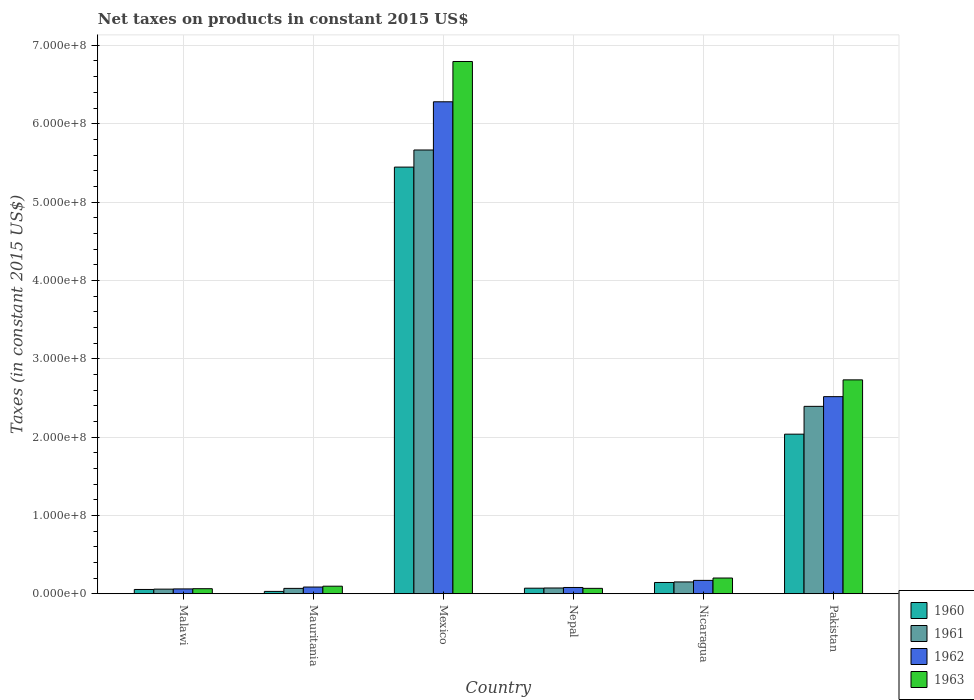Are the number of bars on each tick of the X-axis equal?
Your answer should be compact. Yes. How many bars are there on the 3rd tick from the left?
Offer a terse response. 4. What is the label of the 4th group of bars from the left?
Your response must be concise. Nepal. What is the net taxes on products in 1962 in Mauritania?
Offer a terse response. 8.56e+06. Across all countries, what is the maximum net taxes on products in 1960?
Ensure brevity in your answer.  5.45e+08. Across all countries, what is the minimum net taxes on products in 1960?
Offer a very short reply. 3.00e+06. In which country was the net taxes on products in 1962 minimum?
Provide a succinct answer. Malawi. What is the total net taxes on products in 1960 in the graph?
Your answer should be very brief. 7.78e+08. What is the difference between the net taxes on products in 1962 in Malawi and that in Mexico?
Your answer should be compact. -6.22e+08. What is the difference between the net taxes on products in 1961 in Mexico and the net taxes on products in 1963 in Nicaragua?
Ensure brevity in your answer.  5.46e+08. What is the average net taxes on products in 1962 per country?
Make the answer very short. 1.53e+08. What is the difference between the net taxes on products of/in 1962 and net taxes on products of/in 1961 in Malawi?
Keep it short and to the point. 2.80e+05. In how many countries, is the net taxes on products in 1962 greater than 380000000 US$?
Give a very brief answer. 1. What is the ratio of the net taxes on products in 1961 in Malawi to that in Nepal?
Your response must be concise. 0.8. Is the net taxes on products in 1960 in Malawi less than that in Nicaragua?
Your answer should be compact. Yes. What is the difference between the highest and the second highest net taxes on products in 1962?
Give a very brief answer. 2.35e+08. What is the difference between the highest and the lowest net taxes on products in 1961?
Provide a short and direct response. 5.61e+08. In how many countries, is the net taxes on products in 1961 greater than the average net taxes on products in 1961 taken over all countries?
Your answer should be compact. 2. Is it the case that in every country, the sum of the net taxes on products in 1963 and net taxes on products in 1962 is greater than the net taxes on products in 1960?
Your response must be concise. Yes. How many bars are there?
Offer a very short reply. 24. Are all the bars in the graph horizontal?
Provide a succinct answer. No. What is the difference between two consecutive major ticks on the Y-axis?
Offer a terse response. 1.00e+08. Does the graph contain grids?
Keep it short and to the point. Yes. How many legend labels are there?
Offer a terse response. 4. How are the legend labels stacked?
Your answer should be compact. Vertical. What is the title of the graph?
Provide a short and direct response. Net taxes on products in constant 2015 US$. What is the label or title of the Y-axis?
Keep it short and to the point. Taxes (in constant 2015 US$). What is the Taxes (in constant 2015 US$) of 1960 in Malawi?
Make the answer very short. 5.46e+06. What is the Taxes (in constant 2015 US$) of 1961 in Malawi?
Your answer should be compact. 5.88e+06. What is the Taxes (in constant 2015 US$) of 1962 in Malawi?
Keep it short and to the point. 6.16e+06. What is the Taxes (in constant 2015 US$) in 1963 in Malawi?
Your answer should be very brief. 6.44e+06. What is the Taxes (in constant 2015 US$) of 1960 in Mauritania?
Provide a short and direct response. 3.00e+06. What is the Taxes (in constant 2015 US$) of 1961 in Mauritania?
Make the answer very short. 6.85e+06. What is the Taxes (in constant 2015 US$) in 1962 in Mauritania?
Provide a succinct answer. 8.56e+06. What is the Taxes (in constant 2015 US$) of 1963 in Mauritania?
Keep it short and to the point. 9.63e+06. What is the Taxes (in constant 2015 US$) in 1960 in Mexico?
Your answer should be very brief. 5.45e+08. What is the Taxes (in constant 2015 US$) in 1961 in Mexico?
Your answer should be very brief. 5.66e+08. What is the Taxes (in constant 2015 US$) of 1962 in Mexico?
Provide a short and direct response. 6.28e+08. What is the Taxes (in constant 2015 US$) of 1963 in Mexico?
Your response must be concise. 6.79e+08. What is the Taxes (in constant 2015 US$) of 1960 in Nepal?
Ensure brevity in your answer.  7.09e+06. What is the Taxes (in constant 2015 US$) in 1961 in Nepal?
Ensure brevity in your answer.  7.35e+06. What is the Taxes (in constant 2015 US$) in 1962 in Nepal?
Make the answer very short. 8.01e+06. What is the Taxes (in constant 2015 US$) of 1963 in Nepal?
Your answer should be compact. 6.89e+06. What is the Taxes (in constant 2015 US$) in 1960 in Nicaragua?
Make the answer very short. 1.44e+07. What is the Taxes (in constant 2015 US$) of 1961 in Nicaragua?
Ensure brevity in your answer.  1.51e+07. What is the Taxes (in constant 2015 US$) of 1962 in Nicaragua?
Your answer should be compact. 1.71e+07. What is the Taxes (in constant 2015 US$) of 1963 in Nicaragua?
Ensure brevity in your answer.  2.01e+07. What is the Taxes (in constant 2015 US$) of 1960 in Pakistan?
Provide a succinct answer. 2.04e+08. What is the Taxes (in constant 2015 US$) of 1961 in Pakistan?
Make the answer very short. 2.39e+08. What is the Taxes (in constant 2015 US$) of 1962 in Pakistan?
Keep it short and to the point. 2.52e+08. What is the Taxes (in constant 2015 US$) of 1963 in Pakistan?
Make the answer very short. 2.73e+08. Across all countries, what is the maximum Taxes (in constant 2015 US$) in 1960?
Make the answer very short. 5.45e+08. Across all countries, what is the maximum Taxes (in constant 2015 US$) in 1961?
Ensure brevity in your answer.  5.66e+08. Across all countries, what is the maximum Taxes (in constant 2015 US$) of 1962?
Give a very brief answer. 6.28e+08. Across all countries, what is the maximum Taxes (in constant 2015 US$) in 1963?
Provide a succinct answer. 6.79e+08. Across all countries, what is the minimum Taxes (in constant 2015 US$) in 1960?
Your response must be concise. 3.00e+06. Across all countries, what is the minimum Taxes (in constant 2015 US$) in 1961?
Your answer should be compact. 5.88e+06. Across all countries, what is the minimum Taxes (in constant 2015 US$) in 1962?
Your response must be concise. 6.16e+06. Across all countries, what is the minimum Taxes (in constant 2015 US$) of 1963?
Your response must be concise. 6.44e+06. What is the total Taxes (in constant 2015 US$) of 1960 in the graph?
Provide a succinct answer. 7.78e+08. What is the total Taxes (in constant 2015 US$) of 1961 in the graph?
Your response must be concise. 8.41e+08. What is the total Taxes (in constant 2015 US$) in 1962 in the graph?
Give a very brief answer. 9.19e+08. What is the total Taxes (in constant 2015 US$) in 1963 in the graph?
Provide a succinct answer. 9.95e+08. What is the difference between the Taxes (in constant 2015 US$) in 1960 in Malawi and that in Mauritania?
Keep it short and to the point. 2.46e+06. What is the difference between the Taxes (in constant 2015 US$) of 1961 in Malawi and that in Mauritania?
Provide a succinct answer. -9.67e+05. What is the difference between the Taxes (in constant 2015 US$) of 1962 in Malawi and that in Mauritania?
Make the answer very short. -2.40e+06. What is the difference between the Taxes (in constant 2015 US$) of 1963 in Malawi and that in Mauritania?
Your response must be concise. -3.19e+06. What is the difference between the Taxes (in constant 2015 US$) in 1960 in Malawi and that in Mexico?
Keep it short and to the point. -5.39e+08. What is the difference between the Taxes (in constant 2015 US$) in 1961 in Malawi and that in Mexico?
Your answer should be very brief. -5.61e+08. What is the difference between the Taxes (in constant 2015 US$) of 1962 in Malawi and that in Mexico?
Provide a succinct answer. -6.22e+08. What is the difference between the Taxes (in constant 2015 US$) in 1963 in Malawi and that in Mexico?
Provide a short and direct response. -6.73e+08. What is the difference between the Taxes (in constant 2015 US$) in 1960 in Malawi and that in Nepal?
Provide a succinct answer. -1.63e+06. What is the difference between the Taxes (in constant 2015 US$) in 1961 in Malawi and that in Nepal?
Provide a short and direct response. -1.47e+06. What is the difference between the Taxes (in constant 2015 US$) in 1962 in Malawi and that in Nepal?
Ensure brevity in your answer.  -1.85e+06. What is the difference between the Taxes (in constant 2015 US$) of 1963 in Malawi and that in Nepal?
Provide a short and direct response. -4.50e+05. What is the difference between the Taxes (in constant 2015 US$) of 1960 in Malawi and that in Nicaragua?
Your answer should be very brief. -8.93e+06. What is the difference between the Taxes (in constant 2015 US$) of 1961 in Malawi and that in Nicaragua?
Your answer should be compact. -9.18e+06. What is the difference between the Taxes (in constant 2015 US$) of 1962 in Malawi and that in Nicaragua?
Provide a short and direct response. -1.09e+07. What is the difference between the Taxes (in constant 2015 US$) in 1963 in Malawi and that in Nicaragua?
Offer a terse response. -1.36e+07. What is the difference between the Taxes (in constant 2015 US$) in 1960 in Malawi and that in Pakistan?
Provide a succinct answer. -1.98e+08. What is the difference between the Taxes (in constant 2015 US$) of 1961 in Malawi and that in Pakistan?
Offer a terse response. -2.33e+08. What is the difference between the Taxes (in constant 2015 US$) of 1962 in Malawi and that in Pakistan?
Offer a very short reply. -2.45e+08. What is the difference between the Taxes (in constant 2015 US$) of 1963 in Malawi and that in Pakistan?
Your answer should be very brief. -2.67e+08. What is the difference between the Taxes (in constant 2015 US$) in 1960 in Mauritania and that in Mexico?
Make the answer very short. -5.42e+08. What is the difference between the Taxes (in constant 2015 US$) of 1961 in Mauritania and that in Mexico?
Make the answer very short. -5.60e+08. What is the difference between the Taxes (in constant 2015 US$) in 1962 in Mauritania and that in Mexico?
Your answer should be very brief. -6.19e+08. What is the difference between the Taxes (in constant 2015 US$) of 1963 in Mauritania and that in Mexico?
Offer a very short reply. -6.70e+08. What is the difference between the Taxes (in constant 2015 US$) of 1960 in Mauritania and that in Nepal?
Give a very brief answer. -4.09e+06. What is the difference between the Taxes (in constant 2015 US$) of 1961 in Mauritania and that in Nepal?
Offer a very short reply. -5.03e+05. What is the difference between the Taxes (in constant 2015 US$) of 1962 in Mauritania and that in Nepal?
Your answer should be very brief. 5.53e+05. What is the difference between the Taxes (in constant 2015 US$) in 1963 in Mauritania and that in Nepal?
Offer a terse response. 2.74e+06. What is the difference between the Taxes (in constant 2015 US$) in 1960 in Mauritania and that in Nicaragua?
Provide a succinct answer. -1.14e+07. What is the difference between the Taxes (in constant 2015 US$) of 1961 in Mauritania and that in Nicaragua?
Keep it short and to the point. -8.21e+06. What is the difference between the Taxes (in constant 2015 US$) in 1962 in Mauritania and that in Nicaragua?
Your response must be concise. -8.50e+06. What is the difference between the Taxes (in constant 2015 US$) of 1963 in Mauritania and that in Nicaragua?
Offer a terse response. -1.04e+07. What is the difference between the Taxes (in constant 2015 US$) of 1960 in Mauritania and that in Pakistan?
Ensure brevity in your answer.  -2.01e+08. What is the difference between the Taxes (in constant 2015 US$) of 1961 in Mauritania and that in Pakistan?
Your answer should be compact. -2.32e+08. What is the difference between the Taxes (in constant 2015 US$) in 1962 in Mauritania and that in Pakistan?
Ensure brevity in your answer.  -2.43e+08. What is the difference between the Taxes (in constant 2015 US$) of 1963 in Mauritania and that in Pakistan?
Your answer should be compact. -2.63e+08. What is the difference between the Taxes (in constant 2015 US$) of 1960 in Mexico and that in Nepal?
Your response must be concise. 5.37e+08. What is the difference between the Taxes (in constant 2015 US$) of 1961 in Mexico and that in Nepal?
Offer a terse response. 5.59e+08. What is the difference between the Taxes (in constant 2015 US$) of 1962 in Mexico and that in Nepal?
Make the answer very short. 6.20e+08. What is the difference between the Taxes (in constant 2015 US$) in 1963 in Mexico and that in Nepal?
Provide a short and direct response. 6.72e+08. What is the difference between the Taxes (in constant 2015 US$) in 1960 in Mexico and that in Nicaragua?
Make the answer very short. 5.30e+08. What is the difference between the Taxes (in constant 2015 US$) of 1961 in Mexico and that in Nicaragua?
Provide a short and direct response. 5.51e+08. What is the difference between the Taxes (in constant 2015 US$) in 1962 in Mexico and that in Nicaragua?
Provide a succinct answer. 6.11e+08. What is the difference between the Taxes (in constant 2015 US$) in 1963 in Mexico and that in Nicaragua?
Provide a succinct answer. 6.59e+08. What is the difference between the Taxes (in constant 2015 US$) of 1960 in Mexico and that in Pakistan?
Your answer should be compact. 3.41e+08. What is the difference between the Taxes (in constant 2015 US$) of 1961 in Mexico and that in Pakistan?
Make the answer very short. 3.27e+08. What is the difference between the Taxes (in constant 2015 US$) of 1962 in Mexico and that in Pakistan?
Your response must be concise. 3.76e+08. What is the difference between the Taxes (in constant 2015 US$) in 1963 in Mexico and that in Pakistan?
Your answer should be compact. 4.06e+08. What is the difference between the Taxes (in constant 2015 US$) in 1960 in Nepal and that in Nicaragua?
Offer a terse response. -7.30e+06. What is the difference between the Taxes (in constant 2015 US$) in 1961 in Nepal and that in Nicaragua?
Ensure brevity in your answer.  -7.71e+06. What is the difference between the Taxes (in constant 2015 US$) in 1962 in Nepal and that in Nicaragua?
Your response must be concise. -9.06e+06. What is the difference between the Taxes (in constant 2015 US$) in 1963 in Nepal and that in Nicaragua?
Offer a terse response. -1.32e+07. What is the difference between the Taxes (in constant 2015 US$) of 1960 in Nepal and that in Pakistan?
Your response must be concise. -1.97e+08. What is the difference between the Taxes (in constant 2015 US$) in 1961 in Nepal and that in Pakistan?
Your answer should be compact. -2.32e+08. What is the difference between the Taxes (in constant 2015 US$) in 1962 in Nepal and that in Pakistan?
Ensure brevity in your answer.  -2.44e+08. What is the difference between the Taxes (in constant 2015 US$) of 1963 in Nepal and that in Pakistan?
Offer a terse response. -2.66e+08. What is the difference between the Taxes (in constant 2015 US$) of 1960 in Nicaragua and that in Pakistan?
Your answer should be compact. -1.89e+08. What is the difference between the Taxes (in constant 2015 US$) of 1961 in Nicaragua and that in Pakistan?
Give a very brief answer. -2.24e+08. What is the difference between the Taxes (in constant 2015 US$) in 1962 in Nicaragua and that in Pakistan?
Provide a short and direct response. -2.35e+08. What is the difference between the Taxes (in constant 2015 US$) in 1963 in Nicaragua and that in Pakistan?
Provide a succinct answer. -2.53e+08. What is the difference between the Taxes (in constant 2015 US$) of 1960 in Malawi and the Taxes (in constant 2015 US$) of 1961 in Mauritania?
Offer a terse response. -1.39e+06. What is the difference between the Taxes (in constant 2015 US$) of 1960 in Malawi and the Taxes (in constant 2015 US$) of 1962 in Mauritania?
Your response must be concise. -3.10e+06. What is the difference between the Taxes (in constant 2015 US$) in 1960 in Malawi and the Taxes (in constant 2015 US$) in 1963 in Mauritania?
Your answer should be very brief. -4.17e+06. What is the difference between the Taxes (in constant 2015 US$) of 1961 in Malawi and the Taxes (in constant 2015 US$) of 1962 in Mauritania?
Your answer should be very brief. -2.68e+06. What is the difference between the Taxes (in constant 2015 US$) of 1961 in Malawi and the Taxes (in constant 2015 US$) of 1963 in Mauritania?
Provide a short and direct response. -3.75e+06. What is the difference between the Taxes (in constant 2015 US$) of 1962 in Malawi and the Taxes (in constant 2015 US$) of 1963 in Mauritania?
Offer a very short reply. -3.47e+06. What is the difference between the Taxes (in constant 2015 US$) in 1960 in Malawi and the Taxes (in constant 2015 US$) in 1961 in Mexico?
Ensure brevity in your answer.  -5.61e+08. What is the difference between the Taxes (in constant 2015 US$) in 1960 in Malawi and the Taxes (in constant 2015 US$) in 1962 in Mexico?
Make the answer very short. -6.22e+08. What is the difference between the Taxes (in constant 2015 US$) in 1960 in Malawi and the Taxes (in constant 2015 US$) in 1963 in Mexico?
Your answer should be very brief. -6.74e+08. What is the difference between the Taxes (in constant 2015 US$) in 1961 in Malawi and the Taxes (in constant 2015 US$) in 1962 in Mexico?
Your answer should be compact. -6.22e+08. What is the difference between the Taxes (in constant 2015 US$) of 1961 in Malawi and the Taxes (in constant 2015 US$) of 1963 in Mexico?
Offer a very short reply. -6.73e+08. What is the difference between the Taxes (in constant 2015 US$) in 1962 in Malawi and the Taxes (in constant 2015 US$) in 1963 in Mexico?
Your answer should be compact. -6.73e+08. What is the difference between the Taxes (in constant 2015 US$) in 1960 in Malawi and the Taxes (in constant 2015 US$) in 1961 in Nepal?
Offer a very short reply. -1.89e+06. What is the difference between the Taxes (in constant 2015 US$) of 1960 in Malawi and the Taxes (in constant 2015 US$) of 1962 in Nepal?
Give a very brief answer. -2.55e+06. What is the difference between the Taxes (in constant 2015 US$) of 1960 in Malawi and the Taxes (in constant 2015 US$) of 1963 in Nepal?
Provide a succinct answer. -1.43e+06. What is the difference between the Taxes (in constant 2015 US$) of 1961 in Malawi and the Taxes (in constant 2015 US$) of 1962 in Nepal?
Ensure brevity in your answer.  -2.13e+06. What is the difference between the Taxes (in constant 2015 US$) in 1961 in Malawi and the Taxes (in constant 2015 US$) in 1963 in Nepal?
Your answer should be compact. -1.01e+06. What is the difference between the Taxes (in constant 2015 US$) in 1962 in Malawi and the Taxes (in constant 2015 US$) in 1963 in Nepal?
Offer a very short reply. -7.30e+05. What is the difference between the Taxes (in constant 2015 US$) of 1960 in Malawi and the Taxes (in constant 2015 US$) of 1961 in Nicaragua?
Keep it short and to the point. -9.60e+06. What is the difference between the Taxes (in constant 2015 US$) of 1960 in Malawi and the Taxes (in constant 2015 US$) of 1962 in Nicaragua?
Your answer should be compact. -1.16e+07. What is the difference between the Taxes (in constant 2015 US$) of 1960 in Malawi and the Taxes (in constant 2015 US$) of 1963 in Nicaragua?
Ensure brevity in your answer.  -1.46e+07. What is the difference between the Taxes (in constant 2015 US$) of 1961 in Malawi and the Taxes (in constant 2015 US$) of 1962 in Nicaragua?
Your response must be concise. -1.12e+07. What is the difference between the Taxes (in constant 2015 US$) in 1961 in Malawi and the Taxes (in constant 2015 US$) in 1963 in Nicaragua?
Make the answer very short. -1.42e+07. What is the difference between the Taxes (in constant 2015 US$) in 1962 in Malawi and the Taxes (in constant 2015 US$) in 1963 in Nicaragua?
Offer a very short reply. -1.39e+07. What is the difference between the Taxes (in constant 2015 US$) of 1960 in Malawi and the Taxes (in constant 2015 US$) of 1961 in Pakistan?
Offer a terse response. -2.34e+08. What is the difference between the Taxes (in constant 2015 US$) in 1960 in Malawi and the Taxes (in constant 2015 US$) in 1962 in Pakistan?
Your answer should be very brief. -2.46e+08. What is the difference between the Taxes (in constant 2015 US$) of 1960 in Malawi and the Taxes (in constant 2015 US$) of 1963 in Pakistan?
Your answer should be very brief. -2.68e+08. What is the difference between the Taxes (in constant 2015 US$) of 1961 in Malawi and the Taxes (in constant 2015 US$) of 1962 in Pakistan?
Keep it short and to the point. -2.46e+08. What is the difference between the Taxes (in constant 2015 US$) in 1961 in Malawi and the Taxes (in constant 2015 US$) in 1963 in Pakistan?
Offer a very short reply. -2.67e+08. What is the difference between the Taxes (in constant 2015 US$) in 1962 in Malawi and the Taxes (in constant 2015 US$) in 1963 in Pakistan?
Offer a very short reply. -2.67e+08. What is the difference between the Taxes (in constant 2015 US$) of 1960 in Mauritania and the Taxes (in constant 2015 US$) of 1961 in Mexico?
Your answer should be compact. -5.63e+08. What is the difference between the Taxes (in constant 2015 US$) of 1960 in Mauritania and the Taxes (in constant 2015 US$) of 1962 in Mexico?
Your answer should be very brief. -6.25e+08. What is the difference between the Taxes (in constant 2015 US$) in 1960 in Mauritania and the Taxes (in constant 2015 US$) in 1963 in Mexico?
Offer a very short reply. -6.76e+08. What is the difference between the Taxes (in constant 2015 US$) in 1961 in Mauritania and the Taxes (in constant 2015 US$) in 1962 in Mexico?
Your response must be concise. -6.21e+08. What is the difference between the Taxes (in constant 2015 US$) of 1961 in Mauritania and the Taxes (in constant 2015 US$) of 1963 in Mexico?
Provide a short and direct response. -6.73e+08. What is the difference between the Taxes (in constant 2015 US$) of 1962 in Mauritania and the Taxes (in constant 2015 US$) of 1963 in Mexico?
Provide a succinct answer. -6.71e+08. What is the difference between the Taxes (in constant 2015 US$) in 1960 in Mauritania and the Taxes (in constant 2015 US$) in 1961 in Nepal?
Provide a short and direct response. -4.35e+06. What is the difference between the Taxes (in constant 2015 US$) in 1960 in Mauritania and the Taxes (in constant 2015 US$) in 1962 in Nepal?
Keep it short and to the point. -5.01e+06. What is the difference between the Taxes (in constant 2015 US$) of 1960 in Mauritania and the Taxes (in constant 2015 US$) of 1963 in Nepal?
Give a very brief answer. -3.89e+06. What is the difference between the Taxes (in constant 2015 US$) of 1961 in Mauritania and the Taxes (in constant 2015 US$) of 1962 in Nepal?
Your response must be concise. -1.16e+06. What is the difference between the Taxes (in constant 2015 US$) in 1961 in Mauritania and the Taxes (in constant 2015 US$) in 1963 in Nepal?
Keep it short and to the point. -4.29e+04. What is the difference between the Taxes (in constant 2015 US$) of 1962 in Mauritania and the Taxes (in constant 2015 US$) of 1963 in Nepal?
Offer a terse response. 1.67e+06. What is the difference between the Taxes (in constant 2015 US$) of 1960 in Mauritania and the Taxes (in constant 2015 US$) of 1961 in Nicaragua?
Keep it short and to the point. -1.21e+07. What is the difference between the Taxes (in constant 2015 US$) in 1960 in Mauritania and the Taxes (in constant 2015 US$) in 1962 in Nicaragua?
Make the answer very short. -1.41e+07. What is the difference between the Taxes (in constant 2015 US$) of 1960 in Mauritania and the Taxes (in constant 2015 US$) of 1963 in Nicaragua?
Your answer should be compact. -1.71e+07. What is the difference between the Taxes (in constant 2015 US$) in 1961 in Mauritania and the Taxes (in constant 2015 US$) in 1962 in Nicaragua?
Offer a terse response. -1.02e+07. What is the difference between the Taxes (in constant 2015 US$) of 1961 in Mauritania and the Taxes (in constant 2015 US$) of 1963 in Nicaragua?
Keep it short and to the point. -1.32e+07. What is the difference between the Taxes (in constant 2015 US$) of 1962 in Mauritania and the Taxes (in constant 2015 US$) of 1963 in Nicaragua?
Your answer should be compact. -1.15e+07. What is the difference between the Taxes (in constant 2015 US$) of 1960 in Mauritania and the Taxes (in constant 2015 US$) of 1961 in Pakistan?
Ensure brevity in your answer.  -2.36e+08. What is the difference between the Taxes (in constant 2015 US$) of 1960 in Mauritania and the Taxes (in constant 2015 US$) of 1962 in Pakistan?
Give a very brief answer. -2.49e+08. What is the difference between the Taxes (in constant 2015 US$) of 1960 in Mauritania and the Taxes (in constant 2015 US$) of 1963 in Pakistan?
Provide a succinct answer. -2.70e+08. What is the difference between the Taxes (in constant 2015 US$) of 1961 in Mauritania and the Taxes (in constant 2015 US$) of 1962 in Pakistan?
Offer a terse response. -2.45e+08. What is the difference between the Taxes (in constant 2015 US$) of 1961 in Mauritania and the Taxes (in constant 2015 US$) of 1963 in Pakistan?
Offer a very short reply. -2.66e+08. What is the difference between the Taxes (in constant 2015 US$) in 1962 in Mauritania and the Taxes (in constant 2015 US$) in 1963 in Pakistan?
Offer a terse response. -2.64e+08. What is the difference between the Taxes (in constant 2015 US$) of 1960 in Mexico and the Taxes (in constant 2015 US$) of 1961 in Nepal?
Offer a very short reply. 5.37e+08. What is the difference between the Taxes (in constant 2015 US$) of 1960 in Mexico and the Taxes (in constant 2015 US$) of 1962 in Nepal?
Offer a terse response. 5.37e+08. What is the difference between the Taxes (in constant 2015 US$) of 1960 in Mexico and the Taxes (in constant 2015 US$) of 1963 in Nepal?
Your response must be concise. 5.38e+08. What is the difference between the Taxes (in constant 2015 US$) in 1961 in Mexico and the Taxes (in constant 2015 US$) in 1962 in Nepal?
Give a very brief answer. 5.58e+08. What is the difference between the Taxes (in constant 2015 US$) of 1961 in Mexico and the Taxes (in constant 2015 US$) of 1963 in Nepal?
Your answer should be very brief. 5.60e+08. What is the difference between the Taxes (in constant 2015 US$) in 1962 in Mexico and the Taxes (in constant 2015 US$) in 1963 in Nepal?
Make the answer very short. 6.21e+08. What is the difference between the Taxes (in constant 2015 US$) in 1960 in Mexico and the Taxes (in constant 2015 US$) in 1961 in Nicaragua?
Offer a terse response. 5.30e+08. What is the difference between the Taxes (in constant 2015 US$) in 1960 in Mexico and the Taxes (in constant 2015 US$) in 1962 in Nicaragua?
Your answer should be very brief. 5.28e+08. What is the difference between the Taxes (in constant 2015 US$) of 1960 in Mexico and the Taxes (in constant 2015 US$) of 1963 in Nicaragua?
Your answer should be very brief. 5.24e+08. What is the difference between the Taxes (in constant 2015 US$) in 1961 in Mexico and the Taxes (in constant 2015 US$) in 1962 in Nicaragua?
Provide a succinct answer. 5.49e+08. What is the difference between the Taxes (in constant 2015 US$) of 1961 in Mexico and the Taxes (in constant 2015 US$) of 1963 in Nicaragua?
Give a very brief answer. 5.46e+08. What is the difference between the Taxes (in constant 2015 US$) in 1962 in Mexico and the Taxes (in constant 2015 US$) in 1963 in Nicaragua?
Offer a terse response. 6.08e+08. What is the difference between the Taxes (in constant 2015 US$) of 1960 in Mexico and the Taxes (in constant 2015 US$) of 1961 in Pakistan?
Your answer should be very brief. 3.05e+08. What is the difference between the Taxes (in constant 2015 US$) of 1960 in Mexico and the Taxes (in constant 2015 US$) of 1962 in Pakistan?
Offer a very short reply. 2.93e+08. What is the difference between the Taxes (in constant 2015 US$) of 1960 in Mexico and the Taxes (in constant 2015 US$) of 1963 in Pakistan?
Provide a short and direct response. 2.72e+08. What is the difference between the Taxes (in constant 2015 US$) in 1961 in Mexico and the Taxes (in constant 2015 US$) in 1962 in Pakistan?
Ensure brevity in your answer.  3.15e+08. What is the difference between the Taxes (in constant 2015 US$) of 1961 in Mexico and the Taxes (in constant 2015 US$) of 1963 in Pakistan?
Your answer should be very brief. 2.93e+08. What is the difference between the Taxes (in constant 2015 US$) of 1962 in Mexico and the Taxes (in constant 2015 US$) of 1963 in Pakistan?
Offer a terse response. 3.55e+08. What is the difference between the Taxes (in constant 2015 US$) in 1960 in Nepal and the Taxes (in constant 2015 US$) in 1961 in Nicaragua?
Offer a very short reply. -7.97e+06. What is the difference between the Taxes (in constant 2015 US$) in 1960 in Nepal and the Taxes (in constant 2015 US$) in 1962 in Nicaragua?
Provide a succinct answer. -9.98e+06. What is the difference between the Taxes (in constant 2015 US$) of 1960 in Nepal and the Taxes (in constant 2015 US$) of 1963 in Nicaragua?
Offer a very short reply. -1.30e+07. What is the difference between the Taxes (in constant 2015 US$) of 1961 in Nepal and the Taxes (in constant 2015 US$) of 1962 in Nicaragua?
Your answer should be compact. -9.71e+06. What is the difference between the Taxes (in constant 2015 US$) in 1961 in Nepal and the Taxes (in constant 2015 US$) in 1963 in Nicaragua?
Provide a short and direct response. -1.27e+07. What is the difference between the Taxes (in constant 2015 US$) of 1962 in Nepal and the Taxes (in constant 2015 US$) of 1963 in Nicaragua?
Make the answer very short. -1.21e+07. What is the difference between the Taxes (in constant 2015 US$) of 1960 in Nepal and the Taxes (in constant 2015 US$) of 1961 in Pakistan?
Your answer should be very brief. -2.32e+08. What is the difference between the Taxes (in constant 2015 US$) of 1960 in Nepal and the Taxes (in constant 2015 US$) of 1962 in Pakistan?
Provide a short and direct response. -2.44e+08. What is the difference between the Taxes (in constant 2015 US$) of 1960 in Nepal and the Taxes (in constant 2015 US$) of 1963 in Pakistan?
Offer a terse response. -2.66e+08. What is the difference between the Taxes (in constant 2015 US$) in 1961 in Nepal and the Taxes (in constant 2015 US$) in 1962 in Pakistan?
Provide a short and direct response. -2.44e+08. What is the difference between the Taxes (in constant 2015 US$) of 1961 in Nepal and the Taxes (in constant 2015 US$) of 1963 in Pakistan?
Give a very brief answer. -2.66e+08. What is the difference between the Taxes (in constant 2015 US$) in 1962 in Nepal and the Taxes (in constant 2015 US$) in 1963 in Pakistan?
Ensure brevity in your answer.  -2.65e+08. What is the difference between the Taxes (in constant 2015 US$) of 1960 in Nicaragua and the Taxes (in constant 2015 US$) of 1961 in Pakistan?
Your answer should be compact. -2.25e+08. What is the difference between the Taxes (in constant 2015 US$) in 1960 in Nicaragua and the Taxes (in constant 2015 US$) in 1962 in Pakistan?
Provide a short and direct response. -2.37e+08. What is the difference between the Taxes (in constant 2015 US$) of 1960 in Nicaragua and the Taxes (in constant 2015 US$) of 1963 in Pakistan?
Provide a short and direct response. -2.59e+08. What is the difference between the Taxes (in constant 2015 US$) in 1961 in Nicaragua and the Taxes (in constant 2015 US$) in 1962 in Pakistan?
Ensure brevity in your answer.  -2.37e+08. What is the difference between the Taxes (in constant 2015 US$) in 1961 in Nicaragua and the Taxes (in constant 2015 US$) in 1963 in Pakistan?
Provide a short and direct response. -2.58e+08. What is the difference between the Taxes (in constant 2015 US$) in 1962 in Nicaragua and the Taxes (in constant 2015 US$) in 1963 in Pakistan?
Make the answer very short. -2.56e+08. What is the average Taxes (in constant 2015 US$) in 1960 per country?
Make the answer very short. 1.30e+08. What is the average Taxes (in constant 2015 US$) of 1961 per country?
Provide a succinct answer. 1.40e+08. What is the average Taxes (in constant 2015 US$) of 1962 per country?
Provide a succinct answer. 1.53e+08. What is the average Taxes (in constant 2015 US$) of 1963 per country?
Ensure brevity in your answer.  1.66e+08. What is the difference between the Taxes (in constant 2015 US$) in 1960 and Taxes (in constant 2015 US$) in 1961 in Malawi?
Your answer should be compact. -4.20e+05. What is the difference between the Taxes (in constant 2015 US$) of 1960 and Taxes (in constant 2015 US$) of 1962 in Malawi?
Provide a succinct answer. -7.00e+05. What is the difference between the Taxes (in constant 2015 US$) in 1960 and Taxes (in constant 2015 US$) in 1963 in Malawi?
Your answer should be very brief. -9.80e+05. What is the difference between the Taxes (in constant 2015 US$) of 1961 and Taxes (in constant 2015 US$) of 1962 in Malawi?
Offer a very short reply. -2.80e+05. What is the difference between the Taxes (in constant 2015 US$) in 1961 and Taxes (in constant 2015 US$) in 1963 in Malawi?
Make the answer very short. -5.60e+05. What is the difference between the Taxes (in constant 2015 US$) in 1962 and Taxes (in constant 2015 US$) in 1963 in Malawi?
Your answer should be very brief. -2.80e+05. What is the difference between the Taxes (in constant 2015 US$) of 1960 and Taxes (in constant 2015 US$) of 1961 in Mauritania?
Your answer should be very brief. -3.85e+06. What is the difference between the Taxes (in constant 2015 US$) of 1960 and Taxes (in constant 2015 US$) of 1962 in Mauritania?
Your answer should be very brief. -5.56e+06. What is the difference between the Taxes (in constant 2015 US$) in 1960 and Taxes (in constant 2015 US$) in 1963 in Mauritania?
Make the answer very short. -6.63e+06. What is the difference between the Taxes (in constant 2015 US$) in 1961 and Taxes (in constant 2015 US$) in 1962 in Mauritania?
Provide a short and direct response. -1.71e+06. What is the difference between the Taxes (in constant 2015 US$) of 1961 and Taxes (in constant 2015 US$) of 1963 in Mauritania?
Your answer should be compact. -2.78e+06. What is the difference between the Taxes (in constant 2015 US$) in 1962 and Taxes (in constant 2015 US$) in 1963 in Mauritania?
Give a very brief answer. -1.07e+06. What is the difference between the Taxes (in constant 2015 US$) in 1960 and Taxes (in constant 2015 US$) in 1961 in Mexico?
Your answer should be compact. -2.18e+07. What is the difference between the Taxes (in constant 2015 US$) of 1960 and Taxes (in constant 2015 US$) of 1962 in Mexico?
Offer a very short reply. -8.34e+07. What is the difference between the Taxes (in constant 2015 US$) of 1960 and Taxes (in constant 2015 US$) of 1963 in Mexico?
Make the answer very short. -1.35e+08. What is the difference between the Taxes (in constant 2015 US$) of 1961 and Taxes (in constant 2015 US$) of 1962 in Mexico?
Make the answer very short. -6.15e+07. What is the difference between the Taxes (in constant 2015 US$) of 1961 and Taxes (in constant 2015 US$) of 1963 in Mexico?
Make the answer very short. -1.13e+08. What is the difference between the Taxes (in constant 2015 US$) of 1962 and Taxes (in constant 2015 US$) of 1963 in Mexico?
Offer a very short reply. -5.14e+07. What is the difference between the Taxes (in constant 2015 US$) of 1960 and Taxes (in constant 2015 US$) of 1961 in Nepal?
Your answer should be very brief. -2.63e+05. What is the difference between the Taxes (in constant 2015 US$) of 1960 and Taxes (in constant 2015 US$) of 1962 in Nepal?
Give a very brief answer. -9.19e+05. What is the difference between the Taxes (in constant 2015 US$) in 1960 and Taxes (in constant 2015 US$) in 1963 in Nepal?
Your response must be concise. 1.97e+05. What is the difference between the Taxes (in constant 2015 US$) in 1961 and Taxes (in constant 2015 US$) in 1962 in Nepal?
Provide a short and direct response. -6.56e+05. What is the difference between the Taxes (in constant 2015 US$) of 1961 and Taxes (in constant 2015 US$) of 1963 in Nepal?
Your answer should be very brief. 4.60e+05. What is the difference between the Taxes (in constant 2015 US$) in 1962 and Taxes (in constant 2015 US$) in 1963 in Nepal?
Provide a short and direct response. 1.12e+06. What is the difference between the Taxes (in constant 2015 US$) in 1960 and Taxes (in constant 2015 US$) in 1961 in Nicaragua?
Ensure brevity in your answer.  -6.69e+05. What is the difference between the Taxes (in constant 2015 US$) in 1960 and Taxes (in constant 2015 US$) in 1962 in Nicaragua?
Make the answer very short. -2.68e+06. What is the difference between the Taxes (in constant 2015 US$) of 1960 and Taxes (in constant 2015 US$) of 1963 in Nicaragua?
Make the answer very short. -5.69e+06. What is the difference between the Taxes (in constant 2015 US$) of 1961 and Taxes (in constant 2015 US$) of 1962 in Nicaragua?
Your answer should be very brief. -2.01e+06. What is the difference between the Taxes (in constant 2015 US$) in 1961 and Taxes (in constant 2015 US$) in 1963 in Nicaragua?
Give a very brief answer. -5.02e+06. What is the difference between the Taxes (in constant 2015 US$) of 1962 and Taxes (in constant 2015 US$) of 1963 in Nicaragua?
Offer a terse response. -3.01e+06. What is the difference between the Taxes (in constant 2015 US$) of 1960 and Taxes (in constant 2015 US$) of 1961 in Pakistan?
Offer a terse response. -3.55e+07. What is the difference between the Taxes (in constant 2015 US$) of 1960 and Taxes (in constant 2015 US$) of 1962 in Pakistan?
Keep it short and to the point. -4.79e+07. What is the difference between the Taxes (in constant 2015 US$) of 1960 and Taxes (in constant 2015 US$) of 1963 in Pakistan?
Keep it short and to the point. -6.93e+07. What is the difference between the Taxes (in constant 2015 US$) of 1961 and Taxes (in constant 2015 US$) of 1962 in Pakistan?
Your answer should be very brief. -1.24e+07. What is the difference between the Taxes (in constant 2015 US$) of 1961 and Taxes (in constant 2015 US$) of 1963 in Pakistan?
Your answer should be compact. -3.38e+07. What is the difference between the Taxes (in constant 2015 US$) in 1962 and Taxes (in constant 2015 US$) in 1963 in Pakistan?
Your answer should be very brief. -2.14e+07. What is the ratio of the Taxes (in constant 2015 US$) of 1960 in Malawi to that in Mauritania?
Keep it short and to the point. 1.82. What is the ratio of the Taxes (in constant 2015 US$) of 1961 in Malawi to that in Mauritania?
Your answer should be very brief. 0.86. What is the ratio of the Taxes (in constant 2015 US$) in 1962 in Malawi to that in Mauritania?
Make the answer very short. 0.72. What is the ratio of the Taxes (in constant 2015 US$) of 1963 in Malawi to that in Mauritania?
Your answer should be very brief. 0.67. What is the ratio of the Taxes (in constant 2015 US$) in 1960 in Malawi to that in Mexico?
Your answer should be very brief. 0.01. What is the ratio of the Taxes (in constant 2015 US$) in 1961 in Malawi to that in Mexico?
Your answer should be very brief. 0.01. What is the ratio of the Taxes (in constant 2015 US$) in 1962 in Malawi to that in Mexico?
Your response must be concise. 0.01. What is the ratio of the Taxes (in constant 2015 US$) of 1963 in Malawi to that in Mexico?
Your answer should be very brief. 0.01. What is the ratio of the Taxes (in constant 2015 US$) of 1960 in Malawi to that in Nepal?
Offer a very short reply. 0.77. What is the ratio of the Taxes (in constant 2015 US$) of 1961 in Malawi to that in Nepal?
Ensure brevity in your answer.  0.8. What is the ratio of the Taxes (in constant 2015 US$) of 1962 in Malawi to that in Nepal?
Give a very brief answer. 0.77. What is the ratio of the Taxes (in constant 2015 US$) in 1963 in Malawi to that in Nepal?
Offer a terse response. 0.93. What is the ratio of the Taxes (in constant 2015 US$) of 1960 in Malawi to that in Nicaragua?
Offer a terse response. 0.38. What is the ratio of the Taxes (in constant 2015 US$) of 1961 in Malawi to that in Nicaragua?
Provide a succinct answer. 0.39. What is the ratio of the Taxes (in constant 2015 US$) in 1962 in Malawi to that in Nicaragua?
Give a very brief answer. 0.36. What is the ratio of the Taxes (in constant 2015 US$) in 1963 in Malawi to that in Nicaragua?
Provide a short and direct response. 0.32. What is the ratio of the Taxes (in constant 2015 US$) of 1960 in Malawi to that in Pakistan?
Your answer should be very brief. 0.03. What is the ratio of the Taxes (in constant 2015 US$) of 1961 in Malawi to that in Pakistan?
Make the answer very short. 0.02. What is the ratio of the Taxes (in constant 2015 US$) in 1962 in Malawi to that in Pakistan?
Provide a succinct answer. 0.02. What is the ratio of the Taxes (in constant 2015 US$) in 1963 in Malawi to that in Pakistan?
Your answer should be very brief. 0.02. What is the ratio of the Taxes (in constant 2015 US$) of 1960 in Mauritania to that in Mexico?
Your answer should be very brief. 0.01. What is the ratio of the Taxes (in constant 2015 US$) of 1961 in Mauritania to that in Mexico?
Your answer should be compact. 0.01. What is the ratio of the Taxes (in constant 2015 US$) in 1962 in Mauritania to that in Mexico?
Your answer should be compact. 0.01. What is the ratio of the Taxes (in constant 2015 US$) of 1963 in Mauritania to that in Mexico?
Keep it short and to the point. 0.01. What is the ratio of the Taxes (in constant 2015 US$) of 1960 in Mauritania to that in Nepal?
Make the answer very short. 0.42. What is the ratio of the Taxes (in constant 2015 US$) of 1961 in Mauritania to that in Nepal?
Give a very brief answer. 0.93. What is the ratio of the Taxes (in constant 2015 US$) in 1962 in Mauritania to that in Nepal?
Your answer should be very brief. 1.07. What is the ratio of the Taxes (in constant 2015 US$) in 1963 in Mauritania to that in Nepal?
Ensure brevity in your answer.  1.4. What is the ratio of the Taxes (in constant 2015 US$) of 1960 in Mauritania to that in Nicaragua?
Keep it short and to the point. 0.21. What is the ratio of the Taxes (in constant 2015 US$) of 1961 in Mauritania to that in Nicaragua?
Offer a terse response. 0.45. What is the ratio of the Taxes (in constant 2015 US$) in 1962 in Mauritania to that in Nicaragua?
Offer a terse response. 0.5. What is the ratio of the Taxes (in constant 2015 US$) of 1963 in Mauritania to that in Nicaragua?
Your answer should be very brief. 0.48. What is the ratio of the Taxes (in constant 2015 US$) in 1960 in Mauritania to that in Pakistan?
Keep it short and to the point. 0.01. What is the ratio of the Taxes (in constant 2015 US$) of 1961 in Mauritania to that in Pakistan?
Offer a terse response. 0.03. What is the ratio of the Taxes (in constant 2015 US$) in 1962 in Mauritania to that in Pakistan?
Your answer should be compact. 0.03. What is the ratio of the Taxes (in constant 2015 US$) in 1963 in Mauritania to that in Pakistan?
Provide a succinct answer. 0.04. What is the ratio of the Taxes (in constant 2015 US$) of 1960 in Mexico to that in Nepal?
Keep it short and to the point. 76.83. What is the ratio of the Taxes (in constant 2015 US$) of 1961 in Mexico to that in Nepal?
Offer a very short reply. 77.06. What is the ratio of the Taxes (in constant 2015 US$) in 1962 in Mexico to that in Nepal?
Your answer should be very brief. 78.43. What is the ratio of the Taxes (in constant 2015 US$) of 1963 in Mexico to that in Nepal?
Your answer should be very brief. 98.6. What is the ratio of the Taxes (in constant 2015 US$) in 1960 in Mexico to that in Nicaragua?
Your answer should be very brief. 37.85. What is the ratio of the Taxes (in constant 2015 US$) of 1961 in Mexico to that in Nicaragua?
Your answer should be very brief. 37.62. What is the ratio of the Taxes (in constant 2015 US$) of 1962 in Mexico to that in Nicaragua?
Keep it short and to the point. 36.8. What is the ratio of the Taxes (in constant 2015 US$) of 1963 in Mexico to that in Nicaragua?
Offer a terse response. 33.84. What is the ratio of the Taxes (in constant 2015 US$) of 1960 in Mexico to that in Pakistan?
Offer a very short reply. 2.67. What is the ratio of the Taxes (in constant 2015 US$) in 1961 in Mexico to that in Pakistan?
Make the answer very short. 2.37. What is the ratio of the Taxes (in constant 2015 US$) of 1962 in Mexico to that in Pakistan?
Provide a succinct answer. 2.5. What is the ratio of the Taxes (in constant 2015 US$) in 1963 in Mexico to that in Pakistan?
Offer a very short reply. 2.49. What is the ratio of the Taxes (in constant 2015 US$) in 1960 in Nepal to that in Nicaragua?
Make the answer very short. 0.49. What is the ratio of the Taxes (in constant 2015 US$) in 1961 in Nepal to that in Nicaragua?
Offer a terse response. 0.49. What is the ratio of the Taxes (in constant 2015 US$) in 1962 in Nepal to that in Nicaragua?
Your response must be concise. 0.47. What is the ratio of the Taxes (in constant 2015 US$) in 1963 in Nepal to that in Nicaragua?
Provide a succinct answer. 0.34. What is the ratio of the Taxes (in constant 2015 US$) in 1960 in Nepal to that in Pakistan?
Give a very brief answer. 0.03. What is the ratio of the Taxes (in constant 2015 US$) of 1961 in Nepal to that in Pakistan?
Your answer should be very brief. 0.03. What is the ratio of the Taxes (in constant 2015 US$) in 1962 in Nepal to that in Pakistan?
Give a very brief answer. 0.03. What is the ratio of the Taxes (in constant 2015 US$) in 1963 in Nepal to that in Pakistan?
Offer a terse response. 0.03. What is the ratio of the Taxes (in constant 2015 US$) of 1960 in Nicaragua to that in Pakistan?
Your answer should be compact. 0.07. What is the ratio of the Taxes (in constant 2015 US$) in 1961 in Nicaragua to that in Pakistan?
Provide a succinct answer. 0.06. What is the ratio of the Taxes (in constant 2015 US$) of 1962 in Nicaragua to that in Pakistan?
Provide a succinct answer. 0.07. What is the ratio of the Taxes (in constant 2015 US$) of 1963 in Nicaragua to that in Pakistan?
Your answer should be very brief. 0.07. What is the difference between the highest and the second highest Taxes (in constant 2015 US$) in 1960?
Offer a very short reply. 3.41e+08. What is the difference between the highest and the second highest Taxes (in constant 2015 US$) in 1961?
Your response must be concise. 3.27e+08. What is the difference between the highest and the second highest Taxes (in constant 2015 US$) in 1962?
Provide a short and direct response. 3.76e+08. What is the difference between the highest and the second highest Taxes (in constant 2015 US$) of 1963?
Keep it short and to the point. 4.06e+08. What is the difference between the highest and the lowest Taxes (in constant 2015 US$) of 1960?
Offer a very short reply. 5.42e+08. What is the difference between the highest and the lowest Taxes (in constant 2015 US$) in 1961?
Ensure brevity in your answer.  5.61e+08. What is the difference between the highest and the lowest Taxes (in constant 2015 US$) of 1962?
Give a very brief answer. 6.22e+08. What is the difference between the highest and the lowest Taxes (in constant 2015 US$) in 1963?
Keep it short and to the point. 6.73e+08. 